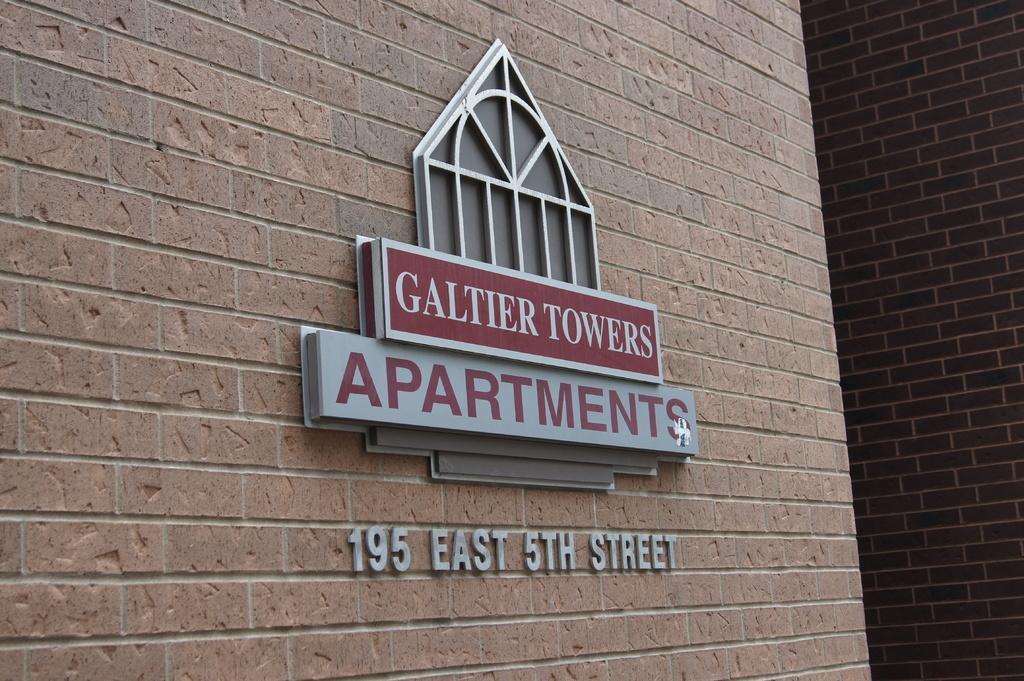Describe this image in one or two sentences. In this image there is a wall, on that wall there is some text written. 